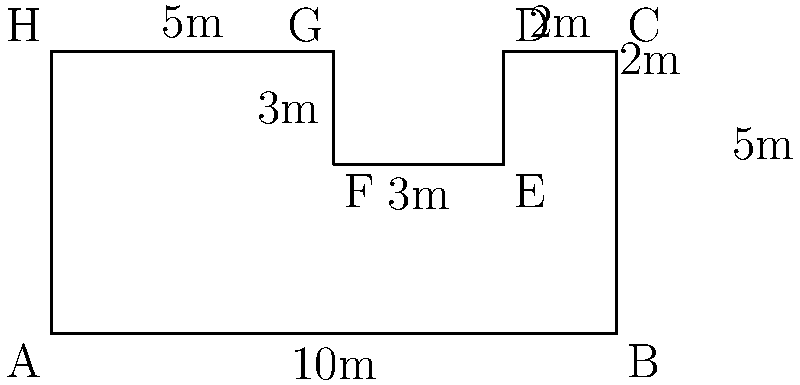As a wellness center manager, you're planning to renovate your yoga studio. The floor plan of the studio is shown above with its dimensions. Calculate the perimeter of the yoga studio floor plan. To calculate the perimeter, we need to add up the lengths of all sides of the irregular shape:

1. Bottom side: $AB = 10$ m
2. Right side: $BC = 5$ m
3. Top-right side: $CD = 2$ m
4. Right indent: $DE = 2$ m
5. Bottom of indent: $EF = 3$ m
6. Left side of indent: $FG = 2$ m
7. Top-left side: $GH = 5$ m
8. Left side: $HA = 5$ m

Adding all these lengths:

$$ \text{Perimeter} = 10 + 5 + 2 + 2 + 3 + 2 + 5 + 5 = 34 \text{ m} $$

Therefore, the perimeter of the yoga studio floor plan is 34 meters.
Answer: 34 m 